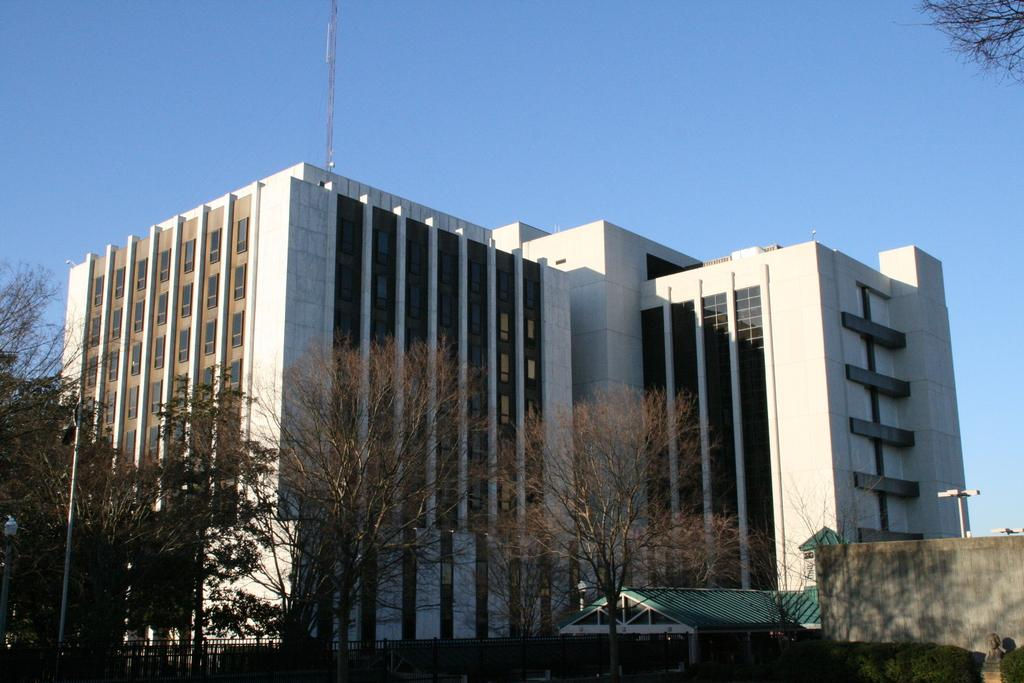What is the main structure in the image? There is a tower in the image. What can be seen in the background of the image? The sky is visible in the image. What type of man-made structures are present in the image? There are buildings in the image. What type of natural elements are present in the image? Trees and bushes are present in the image. What type of utility poles are visible in the image? There are poles in the image. What type of outdoor cooking equipment is visible in the image? A grill is visible in the image. What type of storage structure is present in the image? There is a shed in the image. What type of artistic structure is present in the image? There is a statue in the image. What is the price of the statue in the image? There is no information about the price of the statue in the image. 